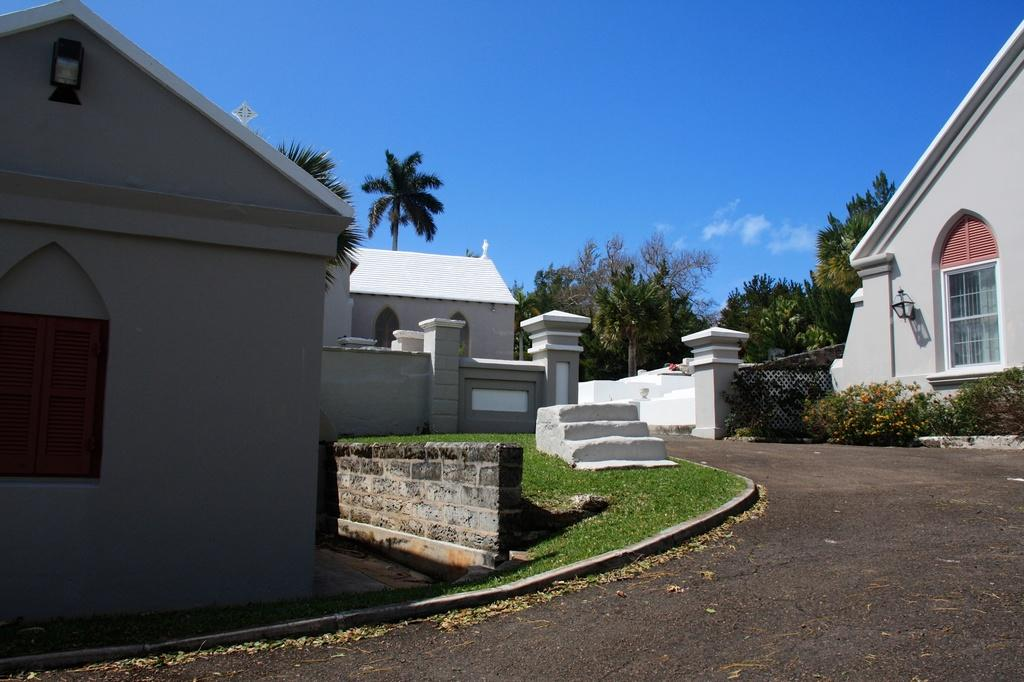What is the color of the house in the image? The house in the image is white. What is located at the bottom front side of the image? There is a road path at the bottom front side of the image. What type of vegetation can be seen in the image? Coconut trees and other trees are visible in the image. What unit of measurement is used to determine the height of the form in the image? There is no form present in the image, so it is not possible to determine a unit of measurement for its height. 